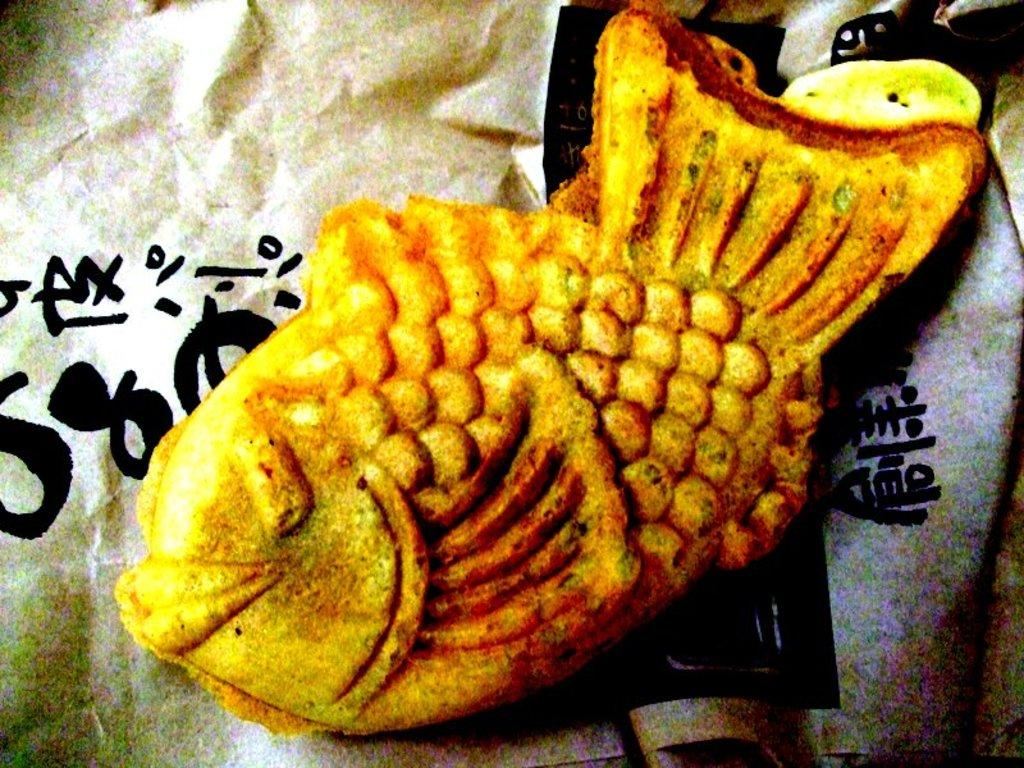What is the main subject of the image? The main subject of the image is food. Can you describe anything else visible in the image? There is a paper visible in the background of the image. How many masses can be seen in the image? There is no mass present in the image. What type of lettuce is being used in the food preparation in the image? There is no lettuce visible in the image. 